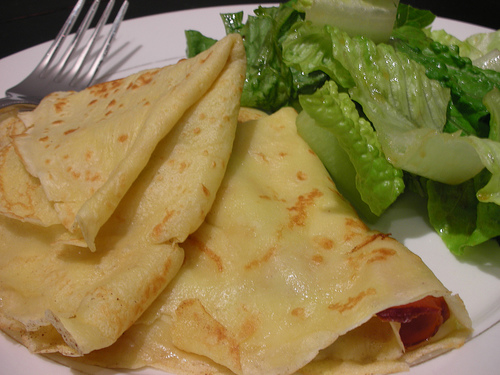<image>
Can you confirm if the crepes is next to the romaine lettuce? Yes. The crepes is positioned adjacent to the romaine lettuce, located nearby in the same general area. 